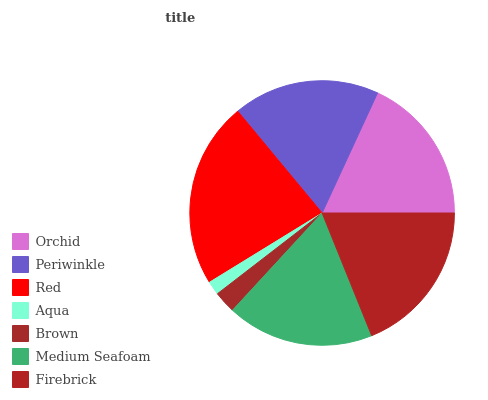Is Aqua the minimum?
Answer yes or no. Yes. Is Red the maximum?
Answer yes or no. Yes. Is Periwinkle the minimum?
Answer yes or no. No. Is Periwinkle the maximum?
Answer yes or no. No. Is Orchid greater than Periwinkle?
Answer yes or no. Yes. Is Periwinkle less than Orchid?
Answer yes or no. Yes. Is Periwinkle greater than Orchid?
Answer yes or no. No. Is Orchid less than Periwinkle?
Answer yes or no. No. Is Medium Seafoam the high median?
Answer yes or no. Yes. Is Medium Seafoam the low median?
Answer yes or no. Yes. Is Firebrick the high median?
Answer yes or no. No. Is Brown the low median?
Answer yes or no. No. 